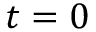Convert formula to latex. <formula><loc_0><loc_0><loc_500><loc_500>t = 0</formula> 